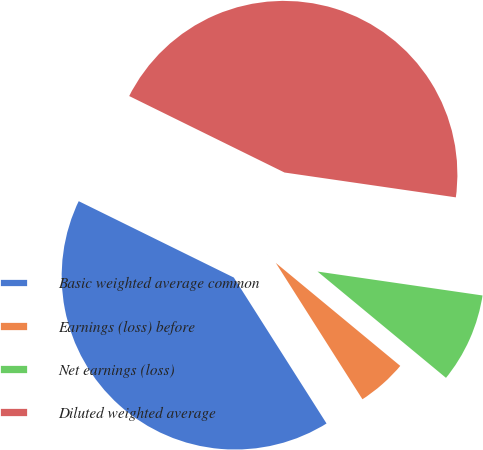<chart> <loc_0><loc_0><loc_500><loc_500><pie_chart><fcel>Basic weighted average common<fcel>Earnings (loss) before<fcel>Net earnings (loss)<fcel>Diluted weighted average<nl><fcel>41.29%<fcel>4.99%<fcel>8.71%<fcel>45.01%<nl></chart> 